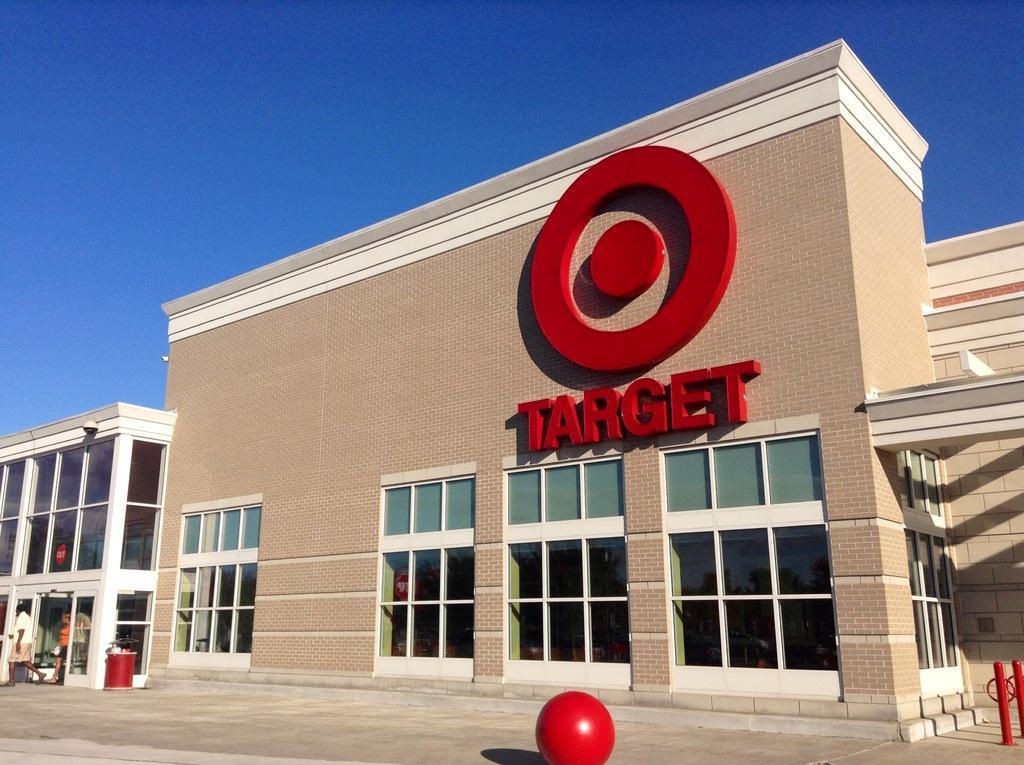Can you describe this image briefly? In the picture I can see a building which has target written on it and there is a red color ball in front of it and there are two persons and a building in the left corner. 